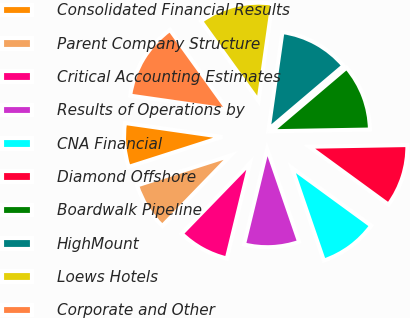Convert chart. <chart><loc_0><loc_0><loc_500><loc_500><pie_chart><fcel>Consolidated Financial Results<fcel>Parent Company Structure<fcel>Critical Accounting Estimates<fcel>Results of Operations by<fcel>CNA Financial<fcel>Diamond Offshore<fcel>Boardwalk Pipeline<fcel>HighMount<fcel>Loews Hotels<fcel>Corporate and Other<nl><fcel>7.2%<fcel>7.82%<fcel>8.45%<fcel>9.07%<fcel>9.69%<fcel>10.31%<fcel>10.93%<fcel>11.55%<fcel>12.18%<fcel>12.8%<nl></chart> 